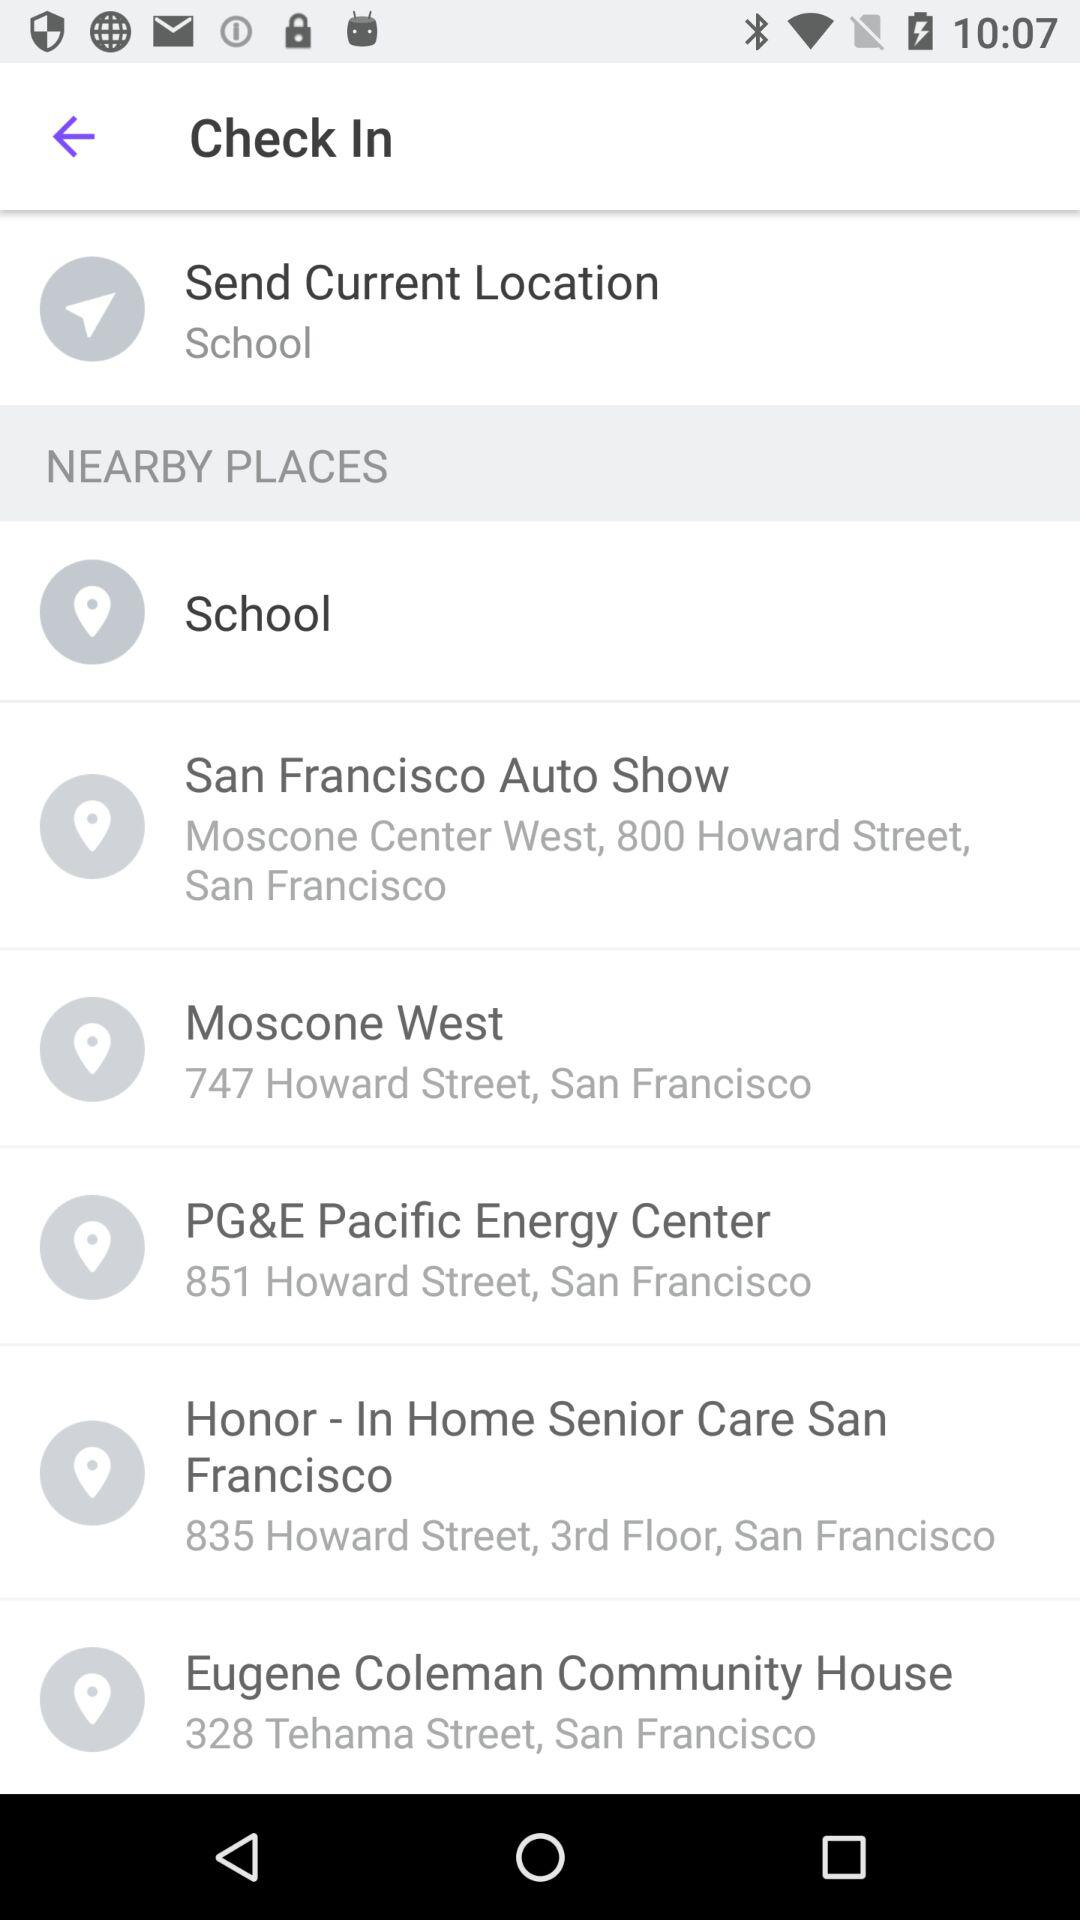What are the available nearby places? The available nearby places are "School", "San Francisco Auto Show", "Moscone West", "PG&E Pacific Energy Center", "Honor - In Home Senior Care San Francisco", and "Eugene Coleman Community House". 